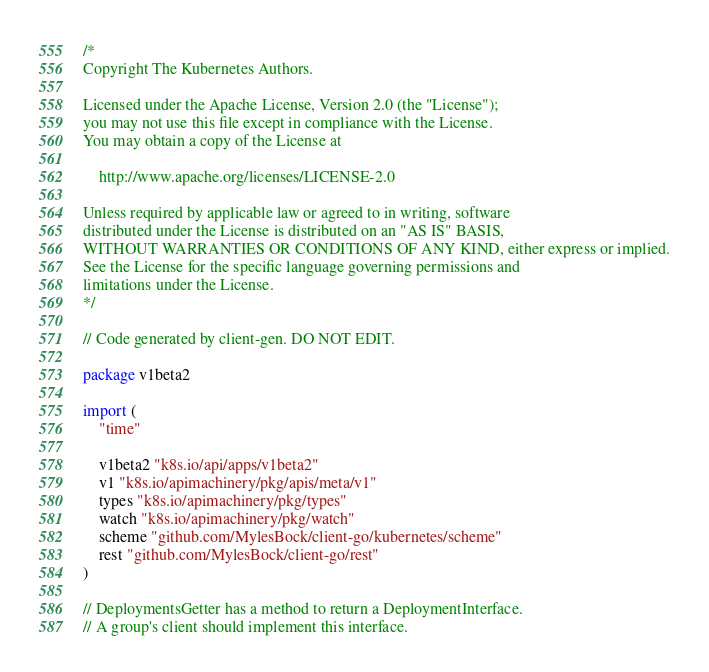<code> <loc_0><loc_0><loc_500><loc_500><_Go_>/*
Copyright The Kubernetes Authors.

Licensed under the Apache License, Version 2.0 (the "License");
you may not use this file except in compliance with the License.
You may obtain a copy of the License at

    http://www.apache.org/licenses/LICENSE-2.0

Unless required by applicable law or agreed to in writing, software
distributed under the License is distributed on an "AS IS" BASIS,
WITHOUT WARRANTIES OR CONDITIONS OF ANY KIND, either express or implied.
See the License for the specific language governing permissions and
limitations under the License.
*/

// Code generated by client-gen. DO NOT EDIT.

package v1beta2

import (
	"time"

	v1beta2 "k8s.io/api/apps/v1beta2"
	v1 "k8s.io/apimachinery/pkg/apis/meta/v1"
	types "k8s.io/apimachinery/pkg/types"
	watch "k8s.io/apimachinery/pkg/watch"
	scheme "github.com/MylesBock/client-go/kubernetes/scheme"
	rest "github.com/MylesBock/client-go/rest"
)

// DeploymentsGetter has a method to return a DeploymentInterface.
// A group's client should implement this interface.</code> 